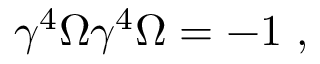Convert formula to latex. <formula><loc_0><loc_0><loc_500><loc_500>\gamma ^ { 4 } \Omega \gamma ^ { 4 } \Omega = - 1 ,</formula> 